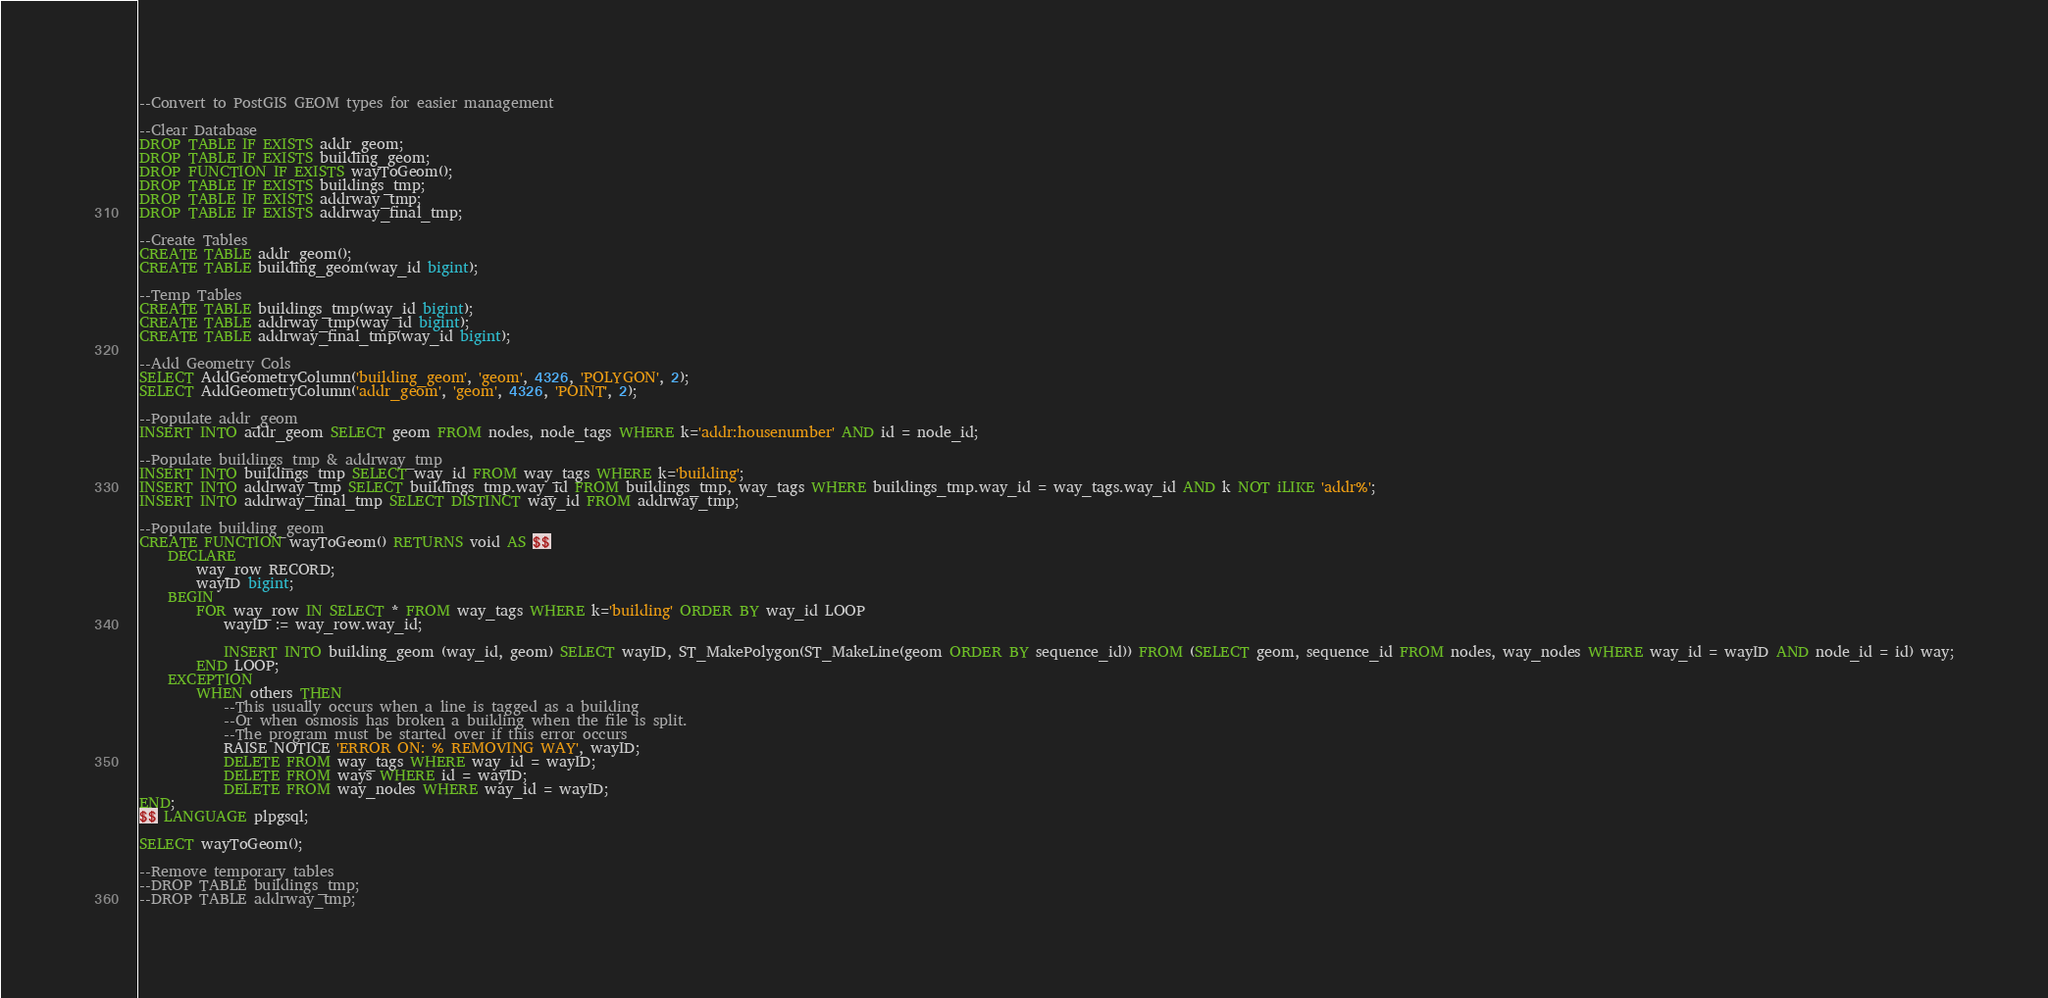<code> <loc_0><loc_0><loc_500><loc_500><_SQL_>--Convert to PostGIS GEOM types for easier management 

--Clear Database
DROP TABLE IF EXISTS addr_geom;
DROP TABLE IF EXISTS building_geom;
DROP FUNCTION IF EXISTS wayToGeom();
DROP TABLE IF EXISTS buildings_tmp;
DROP TABLE IF EXISTS addrway_tmp;
DROP TABLE IF EXISTS addrway_final_tmp;

--Create Tables
CREATE TABLE addr_geom();
CREATE TABLE building_geom(way_id bigint);

--Temp Tables
CREATE TABLE buildings_tmp(way_id bigint);
CREATE TABLE addrway_tmp(way_id bigint);
CREATE TABLE addrway_final_tmp(way_id bigint);

--Add Geometry Cols
SELECT AddGeometryColumn('building_geom', 'geom', 4326, 'POLYGON', 2);
SELECT AddGeometryColumn('addr_geom', 'geom', 4326, 'POINT', 2);

--Populate addr_geom
INSERT INTO addr_geom SELECT geom FROM nodes, node_tags WHERE k='addr:housenumber' AND id = node_id;

--Populate buildings_tmp & addrway_tmp
INSERT INTO buildings_tmp SELECT way_id FROM way_tags WHERE k='building';
INSERT INTO addrway_tmp SELECT buildings_tmp.way_id FROM buildings_tmp, way_tags WHERE buildings_tmp.way_id = way_tags.way_id AND k NOT iLIKE 'addr%';
INSERT INTO addrway_final_tmp SELECT DISTINCT way_id FROM addrway_tmp;

--Populate building_geom
CREATE FUNCTION wayToGeom() RETURNS void AS $$
	DECLARE
		way_row RECORD;
		wayID bigint;
	BEGIN
		FOR way_row IN SELECT * FROM way_tags WHERE k='building' ORDER BY way_id LOOP
			wayID := way_row.way_id;
			
			INSERT INTO building_geom (way_id, geom) SELECT wayID, ST_MakePolygon(ST_MakeLine(geom ORDER BY sequence_id)) FROM (SELECT geom, sequence_id FROM nodes, way_nodes WHERE way_id = wayID AND node_id = id) way;
		END LOOP;
	EXCEPTION
		WHEN others THEN
            --This usually occurs when a line is tagged as a building
            --Or when osmosis has broken a building when the file is split.
            --The program must be started over if this error occurs
            RAISE NOTICE 'ERROR ON: % REMOVING WAY', wayID;
            DELETE FROM way_tags WHERE way_id = wayID;
            DELETE FROM ways WHERE id = wayID;
            DELETE FROM way_nodes WHERE way_id = wayID;
END;
$$ LANGUAGE plpgsql;

SELECT wayToGeom();

--Remove temporary tables
--DROP TABLE buildings_tmp;
--DROP TABLE addrway_tmp;
</code> 